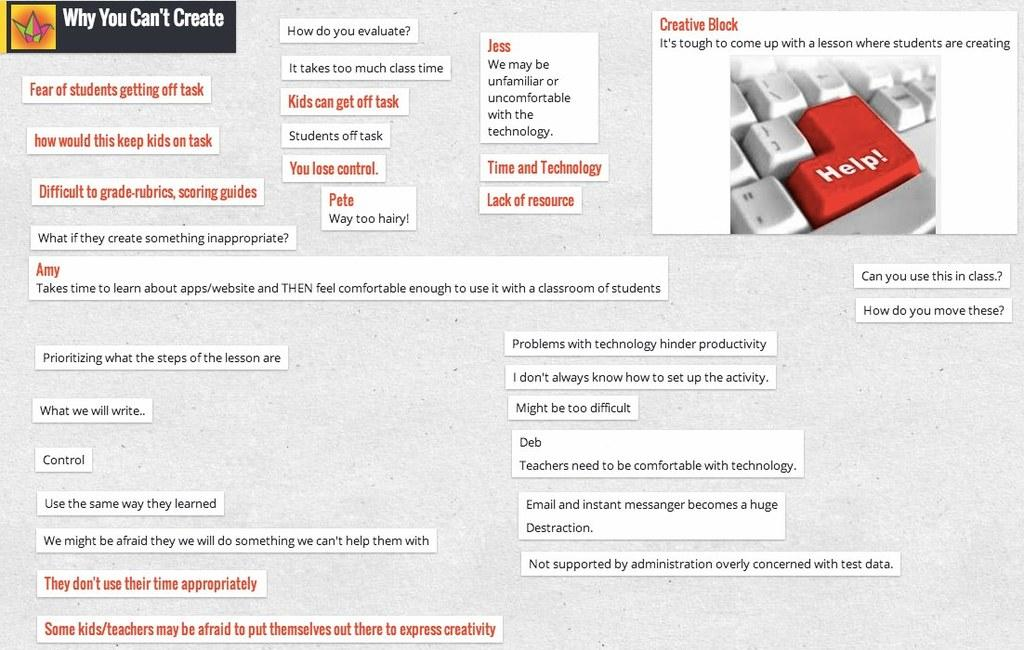<image>
Share a concise interpretation of the image provided. A website page with the words Why You Can't Create in a black box. 